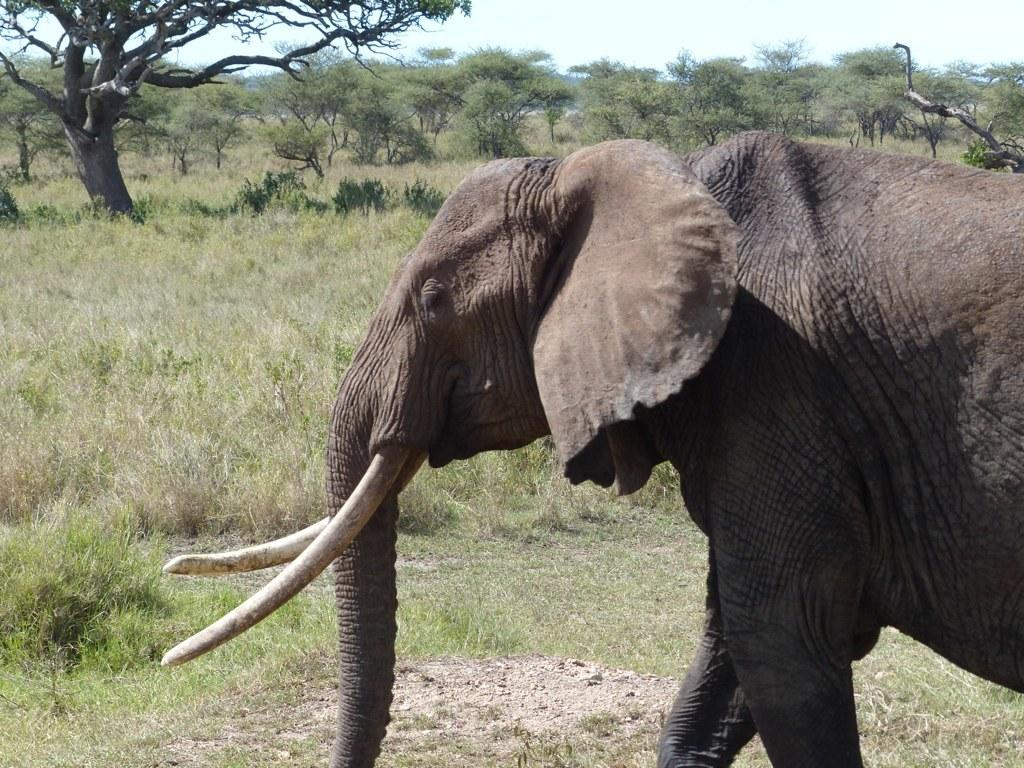What is the main subject in the center of the image? There is an elephant in the center of the image. What can be seen in the background of the image? There are trees in the background of the image. What type of vegetation covers the ground in the image? The ground is covered with grass at the bottom of the image. What type of stomach ailment is the elephant experiencing in the image? There is no indication of any stomach ailment in the image; the elephant appears to be standing normally. 